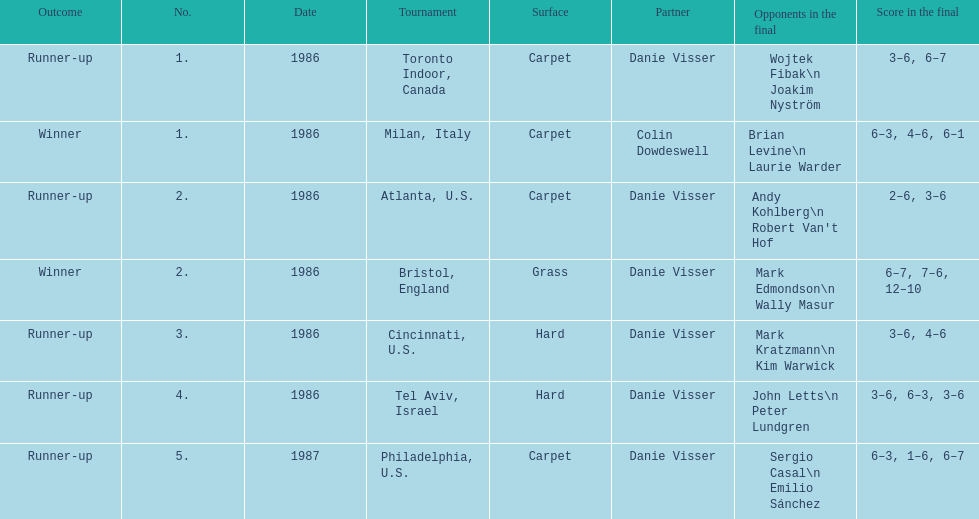What's the total of grass and hard surfaces listed? 3. 